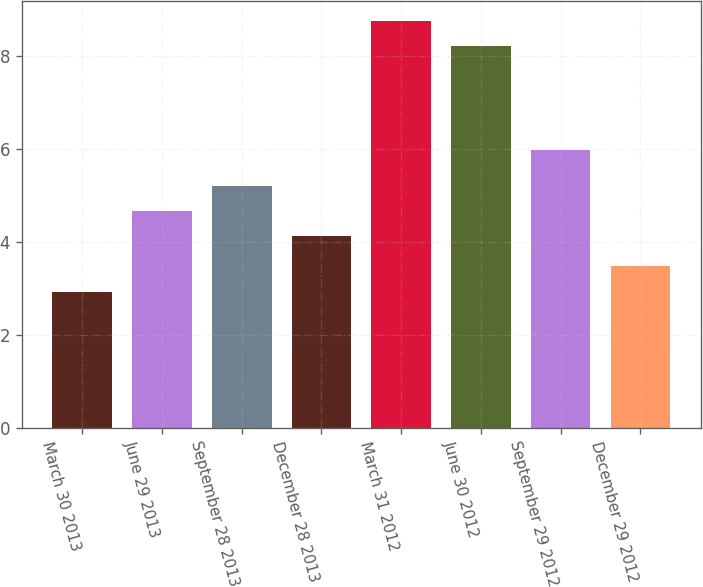Convert chart. <chart><loc_0><loc_0><loc_500><loc_500><bar_chart><fcel>March 30 2013<fcel>June 29 2013<fcel>September 28 2013<fcel>December 28 2013<fcel>March 31 2012<fcel>June 30 2012<fcel>September 29 2012<fcel>December 29 2012<nl><fcel>2.93<fcel>4.67<fcel>5.21<fcel>4.13<fcel>8.75<fcel>8.21<fcel>5.98<fcel>3.47<nl></chart> 